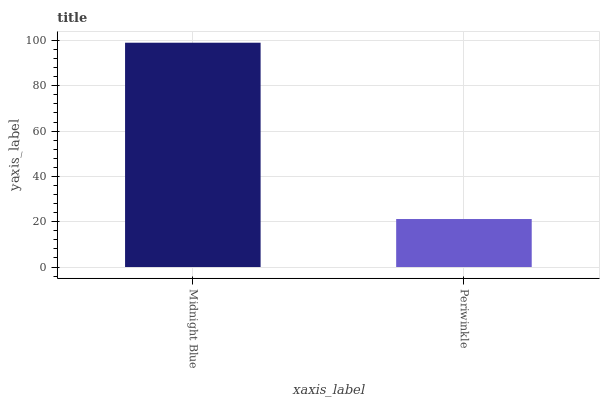Is Periwinkle the minimum?
Answer yes or no. Yes. Is Midnight Blue the maximum?
Answer yes or no. Yes. Is Periwinkle the maximum?
Answer yes or no. No. Is Midnight Blue greater than Periwinkle?
Answer yes or no. Yes. Is Periwinkle less than Midnight Blue?
Answer yes or no. Yes. Is Periwinkle greater than Midnight Blue?
Answer yes or no. No. Is Midnight Blue less than Periwinkle?
Answer yes or no. No. Is Midnight Blue the high median?
Answer yes or no. Yes. Is Periwinkle the low median?
Answer yes or no. Yes. Is Periwinkle the high median?
Answer yes or no. No. Is Midnight Blue the low median?
Answer yes or no. No. 